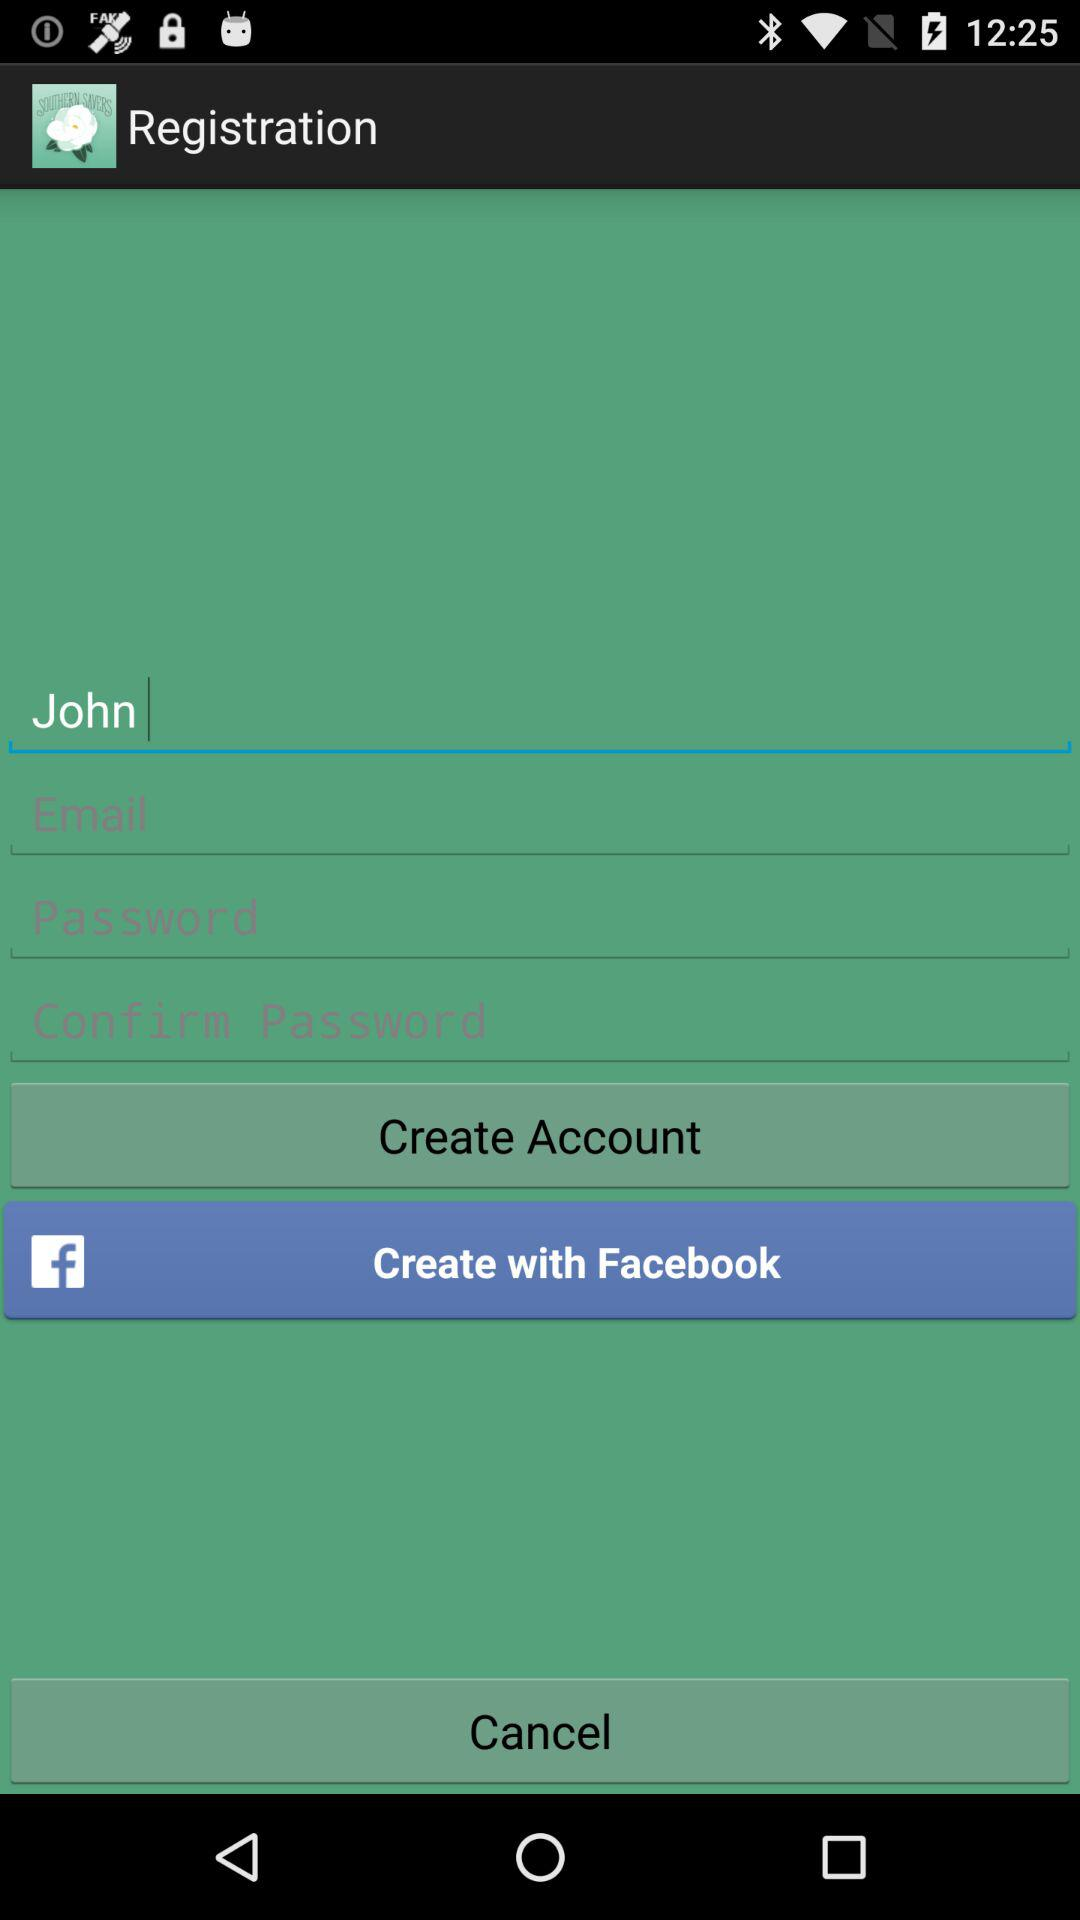What is the user name? The user name is John. 